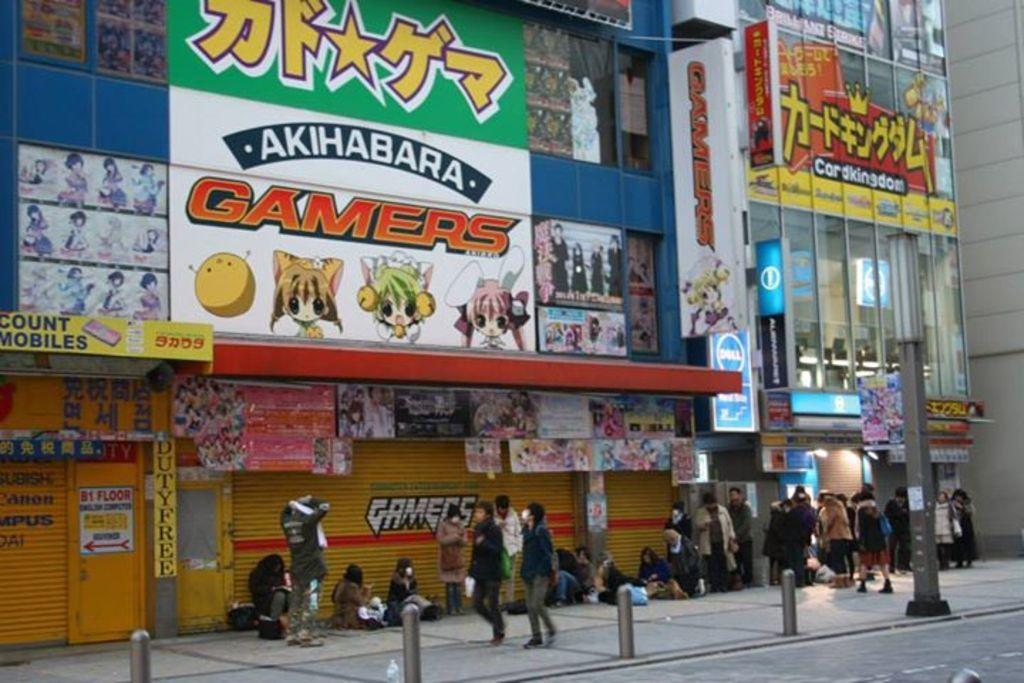Where was the image taken? The image was taken outside. What can be seen in the middle of the image? There are stores in the middle of the image. What are the people at the bottom of the image doing? There are persons walking and sitting at the bottom of the image. What type of pie is being served at the store in the image? There is no pie visible in the image, and it is not mentioned that any store is serving pie. 